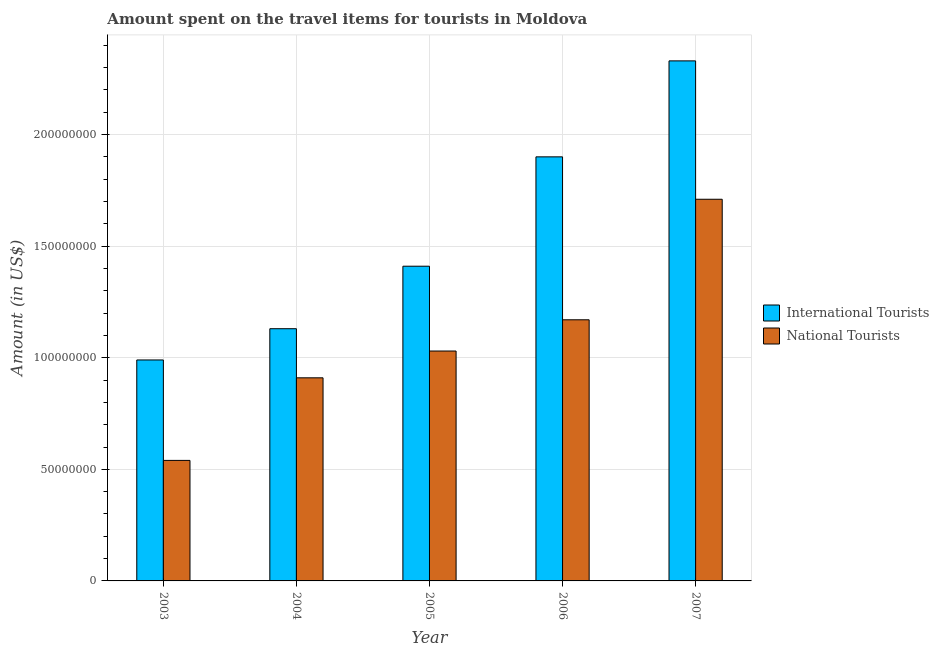Are the number of bars per tick equal to the number of legend labels?
Your answer should be compact. Yes. Are the number of bars on each tick of the X-axis equal?
Give a very brief answer. Yes. How many bars are there on the 1st tick from the right?
Offer a very short reply. 2. What is the amount spent on travel items of international tourists in 2006?
Offer a terse response. 1.90e+08. Across all years, what is the maximum amount spent on travel items of national tourists?
Ensure brevity in your answer.  1.71e+08. Across all years, what is the minimum amount spent on travel items of national tourists?
Provide a succinct answer. 5.40e+07. In which year was the amount spent on travel items of national tourists maximum?
Ensure brevity in your answer.  2007. In which year was the amount spent on travel items of international tourists minimum?
Your response must be concise. 2003. What is the total amount spent on travel items of national tourists in the graph?
Offer a terse response. 5.36e+08. What is the difference between the amount spent on travel items of national tourists in 2003 and that in 2006?
Keep it short and to the point. -6.30e+07. What is the difference between the amount spent on travel items of international tourists in 2003 and the amount spent on travel items of national tourists in 2006?
Keep it short and to the point. -9.10e+07. What is the average amount spent on travel items of international tourists per year?
Your response must be concise. 1.55e+08. In how many years, is the amount spent on travel items of international tourists greater than 120000000 US$?
Make the answer very short. 3. What is the ratio of the amount spent on travel items of national tourists in 2004 to that in 2005?
Your answer should be very brief. 0.88. Is the amount spent on travel items of national tourists in 2004 less than that in 2005?
Provide a succinct answer. Yes. Is the difference between the amount spent on travel items of international tourists in 2003 and 2006 greater than the difference between the amount spent on travel items of national tourists in 2003 and 2006?
Your answer should be compact. No. What is the difference between the highest and the second highest amount spent on travel items of national tourists?
Provide a succinct answer. 5.40e+07. What is the difference between the highest and the lowest amount spent on travel items of national tourists?
Offer a very short reply. 1.17e+08. In how many years, is the amount spent on travel items of national tourists greater than the average amount spent on travel items of national tourists taken over all years?
Ensure brevity in your answer.  2. What does the 1st bar from the left in 2006 represents?
Keep it short and to the point. International Tourists. What does the 1st bar from the right in 2004 represents?
Keep it short and to the point. National Tourists. How many bars are there?
Provide a succinct answer. 10. Are all the bars in the graph horizontal?
Ensure brevity in your answer.  No. Does the graph contain any zero values?
Give a very brief answer. No. Does the graph contain grids?
Keep it short and to the point. Yes. Where does the legend appear in the graph?
Give a very brief answer. Center right. What is the title of the graph?
Offer a very short reply. Amount spent on the travel items for tourists in Moldova. Does "% of GNI" appear as one of the legend labels in the graph?
Your response must be concise. No. What is the Amount (in US$) of International Tourists in 2003?
Your response must be concise. 9.90e+07. What is the Amount (in US$) of National Tourists in 2003?
Your answer should be very brief. 5.40e+07. What is the Amount (in US$) in International Tourists in 2004?
Your answer should be very brief. 1.13e+08. What is the Amount (in US$) of National Tourists in 2004?
Your response must be concise. 9.10e+07. What is the Amount (in US$) in International Tourists in 2005?
Your response must be concise. 1.41e+08. What is the Amount (in US$) of National Tourists in 2005?
Provide a succinct answer. 1.03e+08. What is the Amount (in US$) of International Tourists in 2006?
Offer a terse response. 1.90e+08. What is the Amount (in US$) in National Tourists in 2006?
Offer a terse response. 1.17e+08. What is the Amount (in US$) of International Tourists in 2007?
Your answer should be very brief. 2.33e+08. What is the Amount (in US$) of National Tourists in 2007?
Ensure brevity in your answer.  1.71e+08. Across all years, what is the maximum Amount (in US$) in International Tourists?
Provide a succinct answer. 2.33e+08. Across all years, what is the maximum Amount (in US$) of National Tourists?
Offer a very short reply. 1.71e+08. Across all years, what is the minimum Amount (in US$) of International Tourists?
Give a very brief answer. 9.90e+07. Across all years, what is the minimum Amount (in US$) in National Tourists?
Keep it short and to the point. 5.40e+07. What is the total Amount (in US$) of International Tourists in the graph?
Your answer should be compact. 7.76e+08. What is the total Amount (in US$) of National Tourists in the graph?
Your response must be concise. 5.36e+08. What is the difference between the Amount (in US$) in International Tourists in 2003 and that in 2004?
Make the answer very short. -1.40e+07. What is the difference between the Amount (in US$) of National Tourists in 2003 and that in 2004?
Offer a very short reply. -3.70e+07. What is the difference between the Amount (in US$) in International Tourists in 2003 and that in 2005?
Offer a terse response. -4.20e+07. What is the difference between the Amount (in US$) of National Tourists in 2003 and that in 2005?
Your answer should be very brief. -4.90e+07. What is the difference between the Amount (in US$) in International Tourists in 2003 and that in 2006?
Give a very brief answer. -9.10e+07. What is the difference between the Amount (in US$) in National Tourists in 2003 and that in 2006?
Provide a succinct answer. -6.30e+07. What is the difference between the Amount (in US$) in International Tourists in 2003 and that in 2007?
Your answer should be compact. -1.34e+08. What is the difference between the Amount (in US$) in National Tourists in 2003 and that in 2007?
Your answer should be very brief. -1.17e+08. What is the difference between the Amount (in US$) of International Tourists in 2004 and that in 2005?
Provide a succinct answer. -2.80e+07. What is the difference between the Amount (in US$) of National Tourists in 2004 and that in 2005?
Your response must be concise. -1.20e+07. What is the difference between the Amount (in US$) in International Tourists in 2004 and that in 2006?
Keep it short and to the point. -7.70e+07. What is the difference between the Amount (in US$) in National Tourists in 2004 and that in 2006?
Your answer should be very brief. -2.60e+07. What is the difference between the Amount (in US$) of International Tourists in 2004 and that in 2007?
Give a very brief answer. -1.20e+08. What is the difference between the Amount (in US$) in National Tourists in 2004 and that in 2007?
Make the answer very short. -8.00e+07. What is the difference between the Amount (in US$) of International Tourists in 2005 and that in 2006?
Give a very brief answer. -4.90e+07. What is the difference between the Amount (in US$) in National Tourists in 2005 and that in 2006?
Ensure brevity in your answer.  -1.40e+07. What is the difference between the Amount (in US$) of International Tourists in 2005 and that in 2007?
Provide a succinct answer. -9.20e+07. What is the difference between the Amount (in US$) in National Tourists in 2005 and that in 2007?
Your answer should be very brief. -6.80e+07. What is the difference between the Amount (in US$) in International Tourists in 2006 and that in 2007?
Your answer should be compact. -4.30e+07. What is the difference between the Amount (in US$) of National Tourists in 2006 and that in 2007?
Keep it short and to the point. -5.40e+07. What is the difference between the Amount (in US$) in International Tourists in 2003 and the Amount (in US$) in National Tourists in 2006?
Keep it short and to the point. -1.80e+07. What is the difference between the Amount (in US$) of International Tourists in 2003 and the Amount (in US$) of National Tourists in 2007?
Offer a terse response. -7.20e+07. What is the difference between the Amount (in US$) of International Tourists in 2004 and the Amount (in US$) of National Tourists in 2006?
Your response must be concise. -4.00e+06. What is the difference between the Amount (in US$) in International Tourists in 2004 and the Amount (in US$) in National Tourists in 2007?
Give a very brief answer. -5.80e+07. What is the difference between the Amount (in US$) of International Tourists in 2005 and the Amount (in US$) of National Tourists in 2006?
Ensure brevity in your answer.  2.40e+07. What is the difference between the Amount (in US$) of International Tourists in 2005 and the Amount (in US$) of National Tourists in 2007?
Ensure brevity in your answer.  -3.00e+07. What is the difference between the Amount (in US$) of International Tourists in 2006 and the Amount (in US$) of National Tourists in 2007?
Give a very brief answer. 1.90e+07. What is the average Amount (in US$) of International Tourists per year?
Keep it short and to the point. 1.55e+08. What is the average Amount (in US$) of National Tourists per year?
Your answer should be compact. 1.07e+08. In the year 2003, what is the difference between the Amount (in US$) in International Tourists and Amount (in US$) in National Tourists?
Offer a terse response. 4.50e+07. In the year 2004, what is the difference between the Amount (in US$) in International Tourists and Amount (in US$) in National Tourists?
Offer a very short reply. 2.20e+07. In the year 2005, what is the difference between the Amount (in US$) in International Tourists and Amount (in US$) in National Tourists?
Provide a succinct answer. 3.80e+07. In the year 2006, what is the difference between the Amount (in US$) in International Tourists and Amount (in US$) in National Tourists?
Give a very brief answer. 7.30e+07. In the year 2007, what is the difference between the Amount (in US$) of International Tourists and Amount (in US$) of National Tourists?
Provide a succinct answer. 6.20e+07. What is the ratio of the Amount (in US$) in International Tourists in 2003 to that in 2004?
Offer a very short reply. 0.88. What is the ratio of the Amount (in US$) of National Tourists in 2003 to that in 2004?
Give a very brief answer. 0.59. What is the ratio of the Amount (in US$) of International Tourists in 2003 to that in 2005?
Ensure brevity in your answer.  0.7. What is the ratio of the Amount (in US$) in National Tourists in 2003 to that in 2005?
Your answer should be very brief. 0.52. What is the ratio of the Amount (in US$) in International Tourists in 2003 to that in 2006?
Keep it short and to the point. 0.52. What is the ratio of the Amount (in US$) of National Tourists in 2003 to that in 2006?
Ensure brevity in your answer.  0.46. What is the ratio of the Amount (in US$) of International Tourists in 2003 to that in 2007?
Offer a terse response. 0.42. What is the ratio of the Amount (in US$) in National Tourists in 2003 to that in 2007?
Give a very brief answer. 0.32. What is the ratio of the Amount (in US$) in International Tourists in 2004 to that in 2005?
Your answer should be very brief. 0.8. What is the ratio of the Amount (in US$) of National Tourists in 2004 to that in 2005?
Provide a short and direct response. 0.88. What is the ratio of the Amount (in US$) of International Tourists in 2004 to that in 2006?
Ensure brevity in your answer.  0.59. What is the ratio of the Amount (in US$) of National Tourists in 2004 to that in 2006?
Make the answer very short. 0.78. What is the ratio of the Amount (in US$) of International Tourists in 2004 to that in 2007?
Your answer should be compact. 0.48. What is the ratio of the Amount (in US$) of National Tourists in 2004 to that in 2007?
Keep it short and to the point. 0.53. What is the ratio of the Amount (in US$) in International Tourists in 2005 to that in 2006?
Ensure brevity in your answer.  0.74. What is the ratio of the Amount (in US$) of National Tourists in 2005 to that in 2006?
Offer a terse response. 0.88. What is the ratio of the Amount (in US$) in International Tourists in 2005 to that in 2007?
Offer a terse response. 0.61. What is the ratio of the Amount (in US$) of National Tourists in 2005 to that in 2007?
Make the answer very short. 0.6. What is the ratio of the Amount (in US$) in International Tourists in 2006 to that in 2007?
Give a very brief answer. 0.82. What is the ratio of the Amount (in US$) in National Tourists in 2006 to that in 2007?
Your response must be concise. 0.68. What is the difference between the highest and the second highest Amount (in US$) in International Tourists?
Offer a very short reply. 4.30e+07. What is the difference between the highest and the second highest Amount (in US$) of National Tourists?
Your answer should be compact. 5.40e+07. What is the difference between the highest and the lowest Amount (in US$) in International Tourists?
Provide a short and direct response. 1.34e+08. What is the difference between the highest and the lowest Amount (in US$) in National Tourists?
Keep it short and to the point. 1.17e+08. 